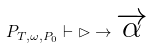Convert formula to latex. <formula><loc_0><loc_0><loc_500><loc_500>P _ { T , \omega , P _ { 0 } } \vdash \rhd \to \overrightarrow { \alpha }</formula> 